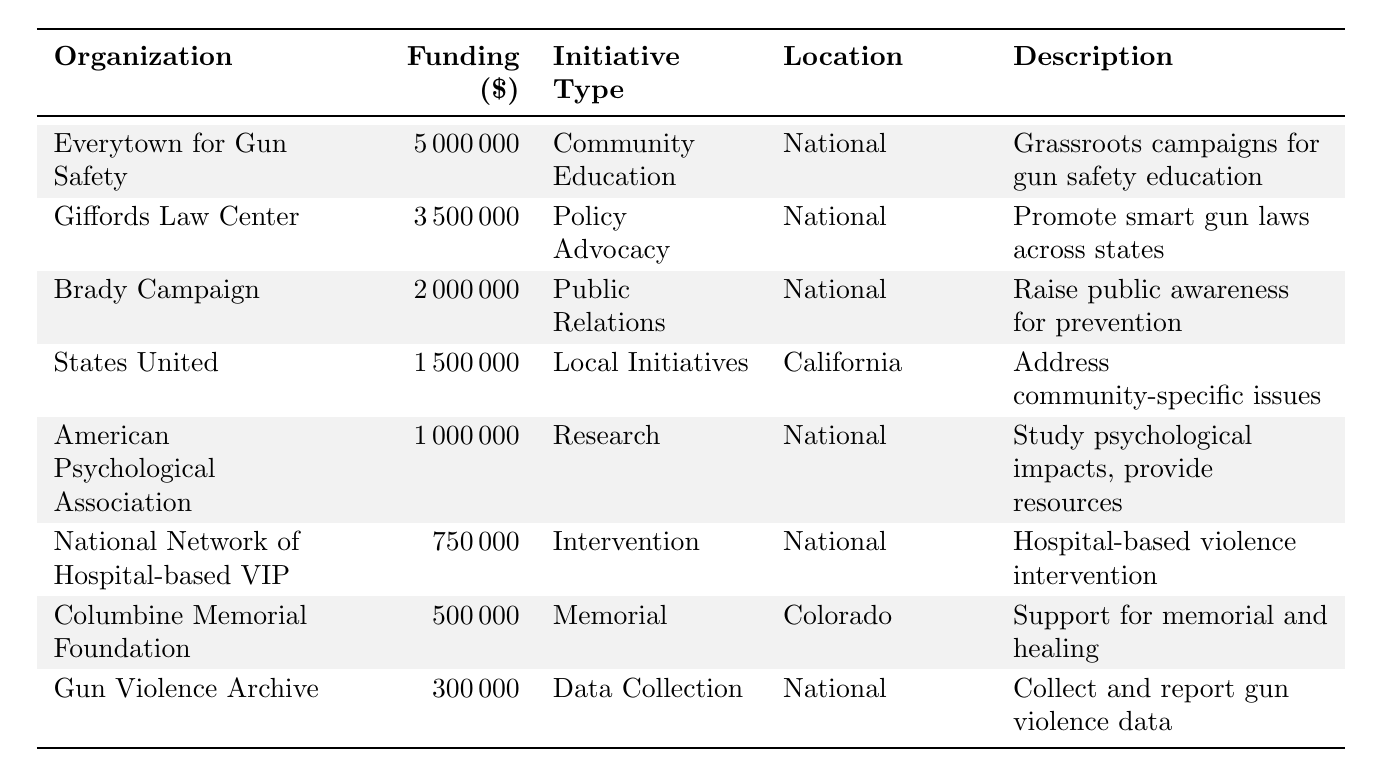What is the total funding amount for gun violence prevention initiatives in 2021? To find the total funding amount, we add all the individual funding amounts together: 5000000 + 3500000 + 2000000 + 1500000 + 1000000 + 750000 + 500000 + 300000 = 11800000.
Answer: 11800000 Which organization received the highest funding amount? Looking at the funding amounts for each organization, Everytown for Gun Safety received the highest amount of 5000000.
Answer: Everytown for Gun Safety How much funding was allocated for local initiatives in California? The funding allocated for local initiatives is 1500000, as indicated for the organization States United to Prevent Gun Violence located in California.
Answer: 1500000 Did the American Psychological Association receive more funding than the Columbine Memorial Foundation? The American Psychological Association received 1000000, while the Columbine Memorial Foundation received 500000. Since 1000000 is greater than 500000, the answer is yes.
Answer: Yes What type of initiative received the least funding and how much was it? The organization with the least funding is Gun Violence Archive, which is classified under Data Collection and Reporting, and it received 300000.
Answer: Data Collection, 300000 What is the average funding amount for the initiatives listed? To find the average, sum all the funding amounts (11800000) and divide by the number of organizations (8): 11800000 / 8 = 1475000.
Answer: 1475000 How many initiatives focused on national efforts compared to local initiatives? There are 6 national initiatives (Everytown, Giffords, Brady, American Psychological Association, National Network, Gun Violence Archive) and 1 local initiative (States United). Therefore, there are more national initiatives than local ones.
Answer: More national initiatives What percentage of the total funding is represented by the Brady Campaign to Prevent Gun Violence? The funding for the Brady Campaign is 2000000. To find the percentage: (2000000 / 11800000) * 100 ≈ 16.95%.
Answer: Approximately 16.95% Which organization focused on intervention programs and how much did they receive? The organization focusing on intervention programs is the National Network of Hospital-based Violence Intervention Programs, and they received 750000.
Answer: National Network of Hospital-based VIP, 750000 Was there any funding directed towards memorial and healing initiatives? Yes, the Columbine Memorial Foundation received 500000 for memorial and healing initiatives as stated in the table.
Answer: Yes 